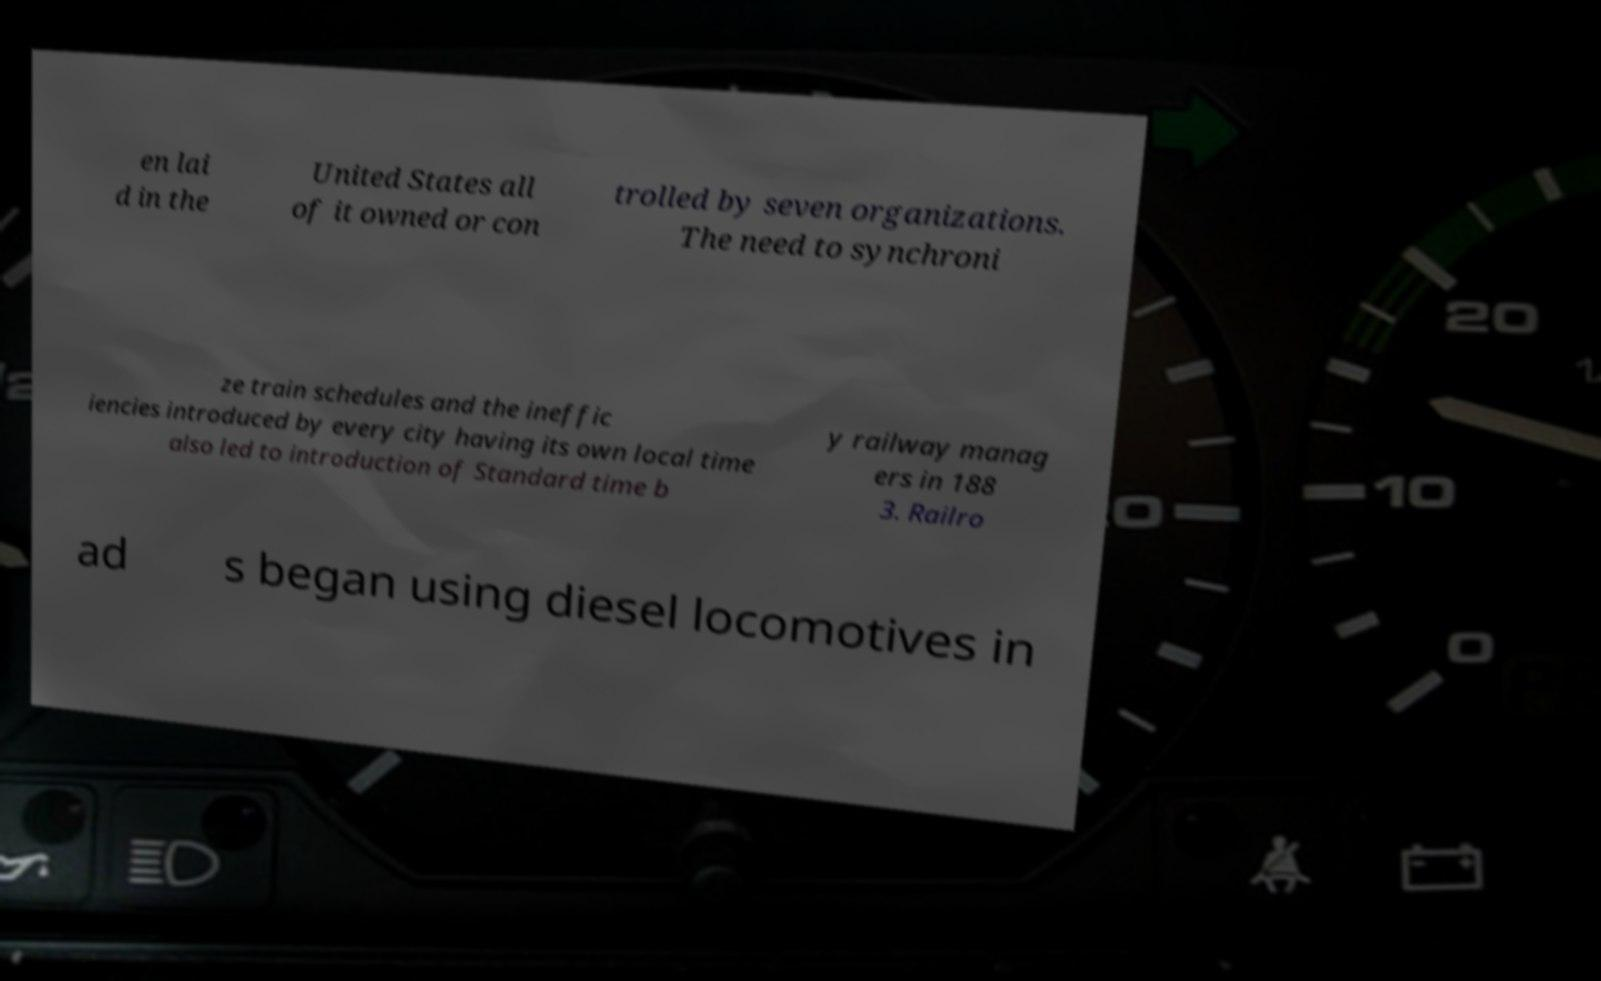There's text embedded in this image that I need extracted. Can you transcribe it verbatim? en lai d in the United States all of it owned or con trolled by seven organizations. The need to synchroni ze train schedules and the ineffic iencies introduced by every city having its own local time also led to introduction of Standard time b y railway manag ers in 188 3. Railro ad s began using diesel locomotives in 